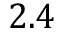<formula> <loc_0><loc_0><loc_500><loc_500>2 . 4</formula> 